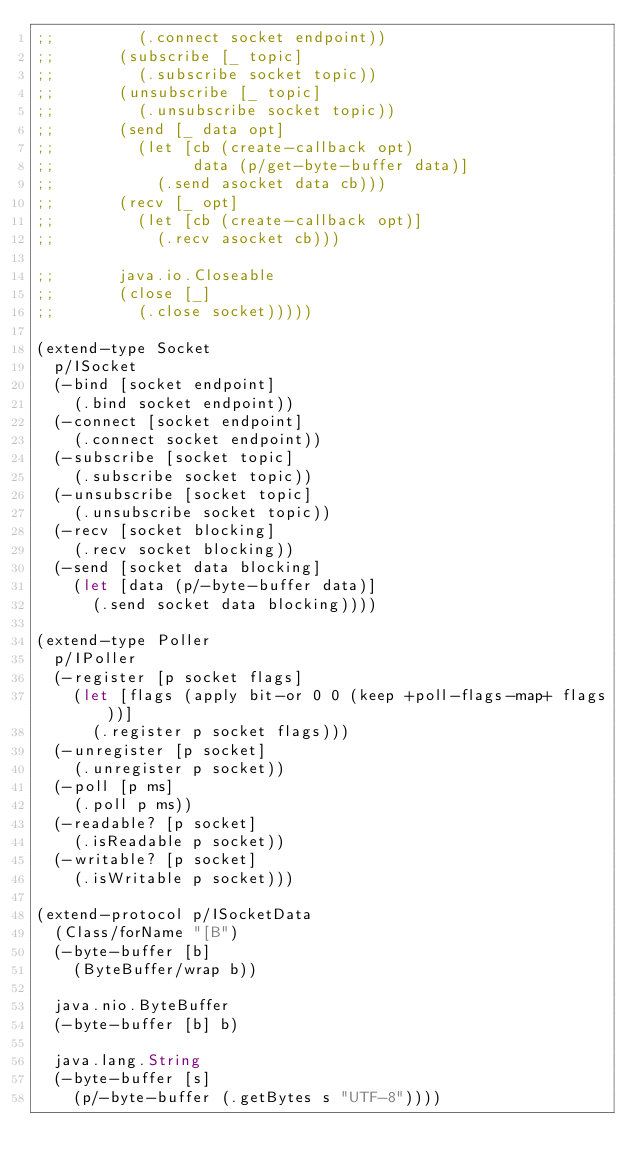Convert code to text. <code><loc_0><loc_0><loc_500><loc_500><_Clojure_>;;         (.connect socket endpoint))
;;       (subscribe [_ topic]
;;         (.subscribe socket topic))
;;       (unsubscribe [_ topic]
;;         (.unsubscribe socket topic))
;;       (send [_ data opt]
;;         (let [cb (create-callback opt)
;;               data (p/get-byte-buffer data)]
;;           (.send asocket data cb)))
;;       (recv [_ opt]
;;         (let [cb (create-callback opt)]
;;           (.recv asocket cb)))

;;       java.io.Closeable
;;       (close [_]
;;         (.close socket)))))

(extend-type Socket
  p/ISocket
  (-bind [socket endpoint]
    (.bind socket endpoint))
  (-connect [socket endpoint]
    (.connect socket endpoint))
  (-subscribe [socket topic]
    (.subscribe socket topic))
  (-unsubscribe [socket topic]
    (.unsubscribe socket topic))
  (-recv [socket blocking]
    (.recv socket blocking))
  (-send [socket data blocking]
    (let [data (p/-byte-buffer data)]
      (.send socket data blocking))))

(extend-type Poller
  p/IPoller
  (-register [p socket flags]
    (let [flags (apply bit-or 0 0 (keep +poll-flags-map+ flags))]
      (.register p socket flags)))
  (-unregister [p socket]
    (.unregister p socket))
  (-poll [p ms]
    (.poll p ms))
  (-readable? [p socket]
    (.isReadable p socket))
  (-writable? [p socket]
    (.isWritable p socket)))

(extend-protocol p/ISocketData
  (Class/forName "[B")
  (-byte-buffer [b]
    (ByteBuffer/wrap b))

  java.nio.ByteBuffer
  (-byte-buffer [b] b)

  java.lang.String
  (-byte-buffer [s]
    (p/-byte-buffer (.getBytes s "UTF-8"))))
</code> 